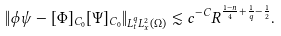Convert formula to latex. <formula><loc_0><loc_0><loc_500><loc_500>\| \phi \psi - [ \Phi ] _ { C _ { 0 } } [ \Psi ] _ { C _ { 0 } } \| _ { L ^ { q } _ { t } L ^ { 2 } _ { x } ( \Omega ) } \lesssim c ^ { - C } R ^ { \frac { 1 - n } { 4 } + \frac { 1 } { q } - \frac { 1 } { 2 } } .</formula> 